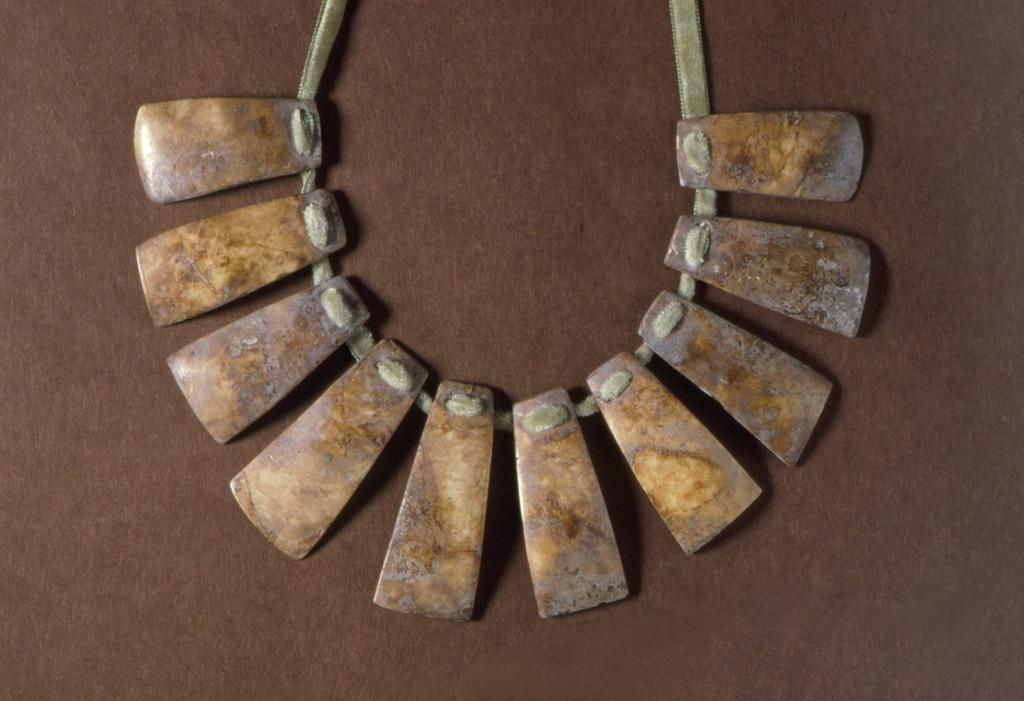What type of object is the image depicting? The image is an ornament. What color is the background of the ornament? The background of the image is brown in color. How many pies are being held by the hand in the image? There are no pies or hands present in the image, as it is an ornament with a brown background. What is the condition of the toe in the image? There is no toe visible in the image, as it is an ornament with a brown background. 